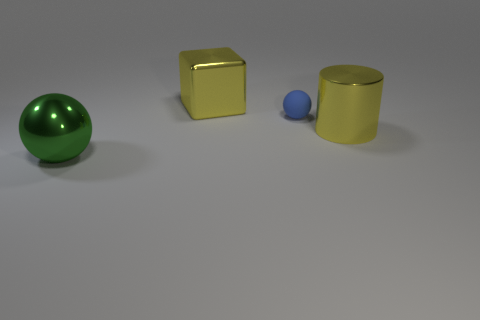Add 1 large red balls. How many objects exist? 5 Subtract all cylinders. How many objects are left? 3 Subtract 1 green spheres. How many objects are left? 3 Subtract all tiny gray balls. Subtract all yellow shiny cylinders. How many objects are left? 3 Add 3 big yellow cubes. How many big yellow cubes are left? 4 Add 2 spheres. How many spheres exist? 4 